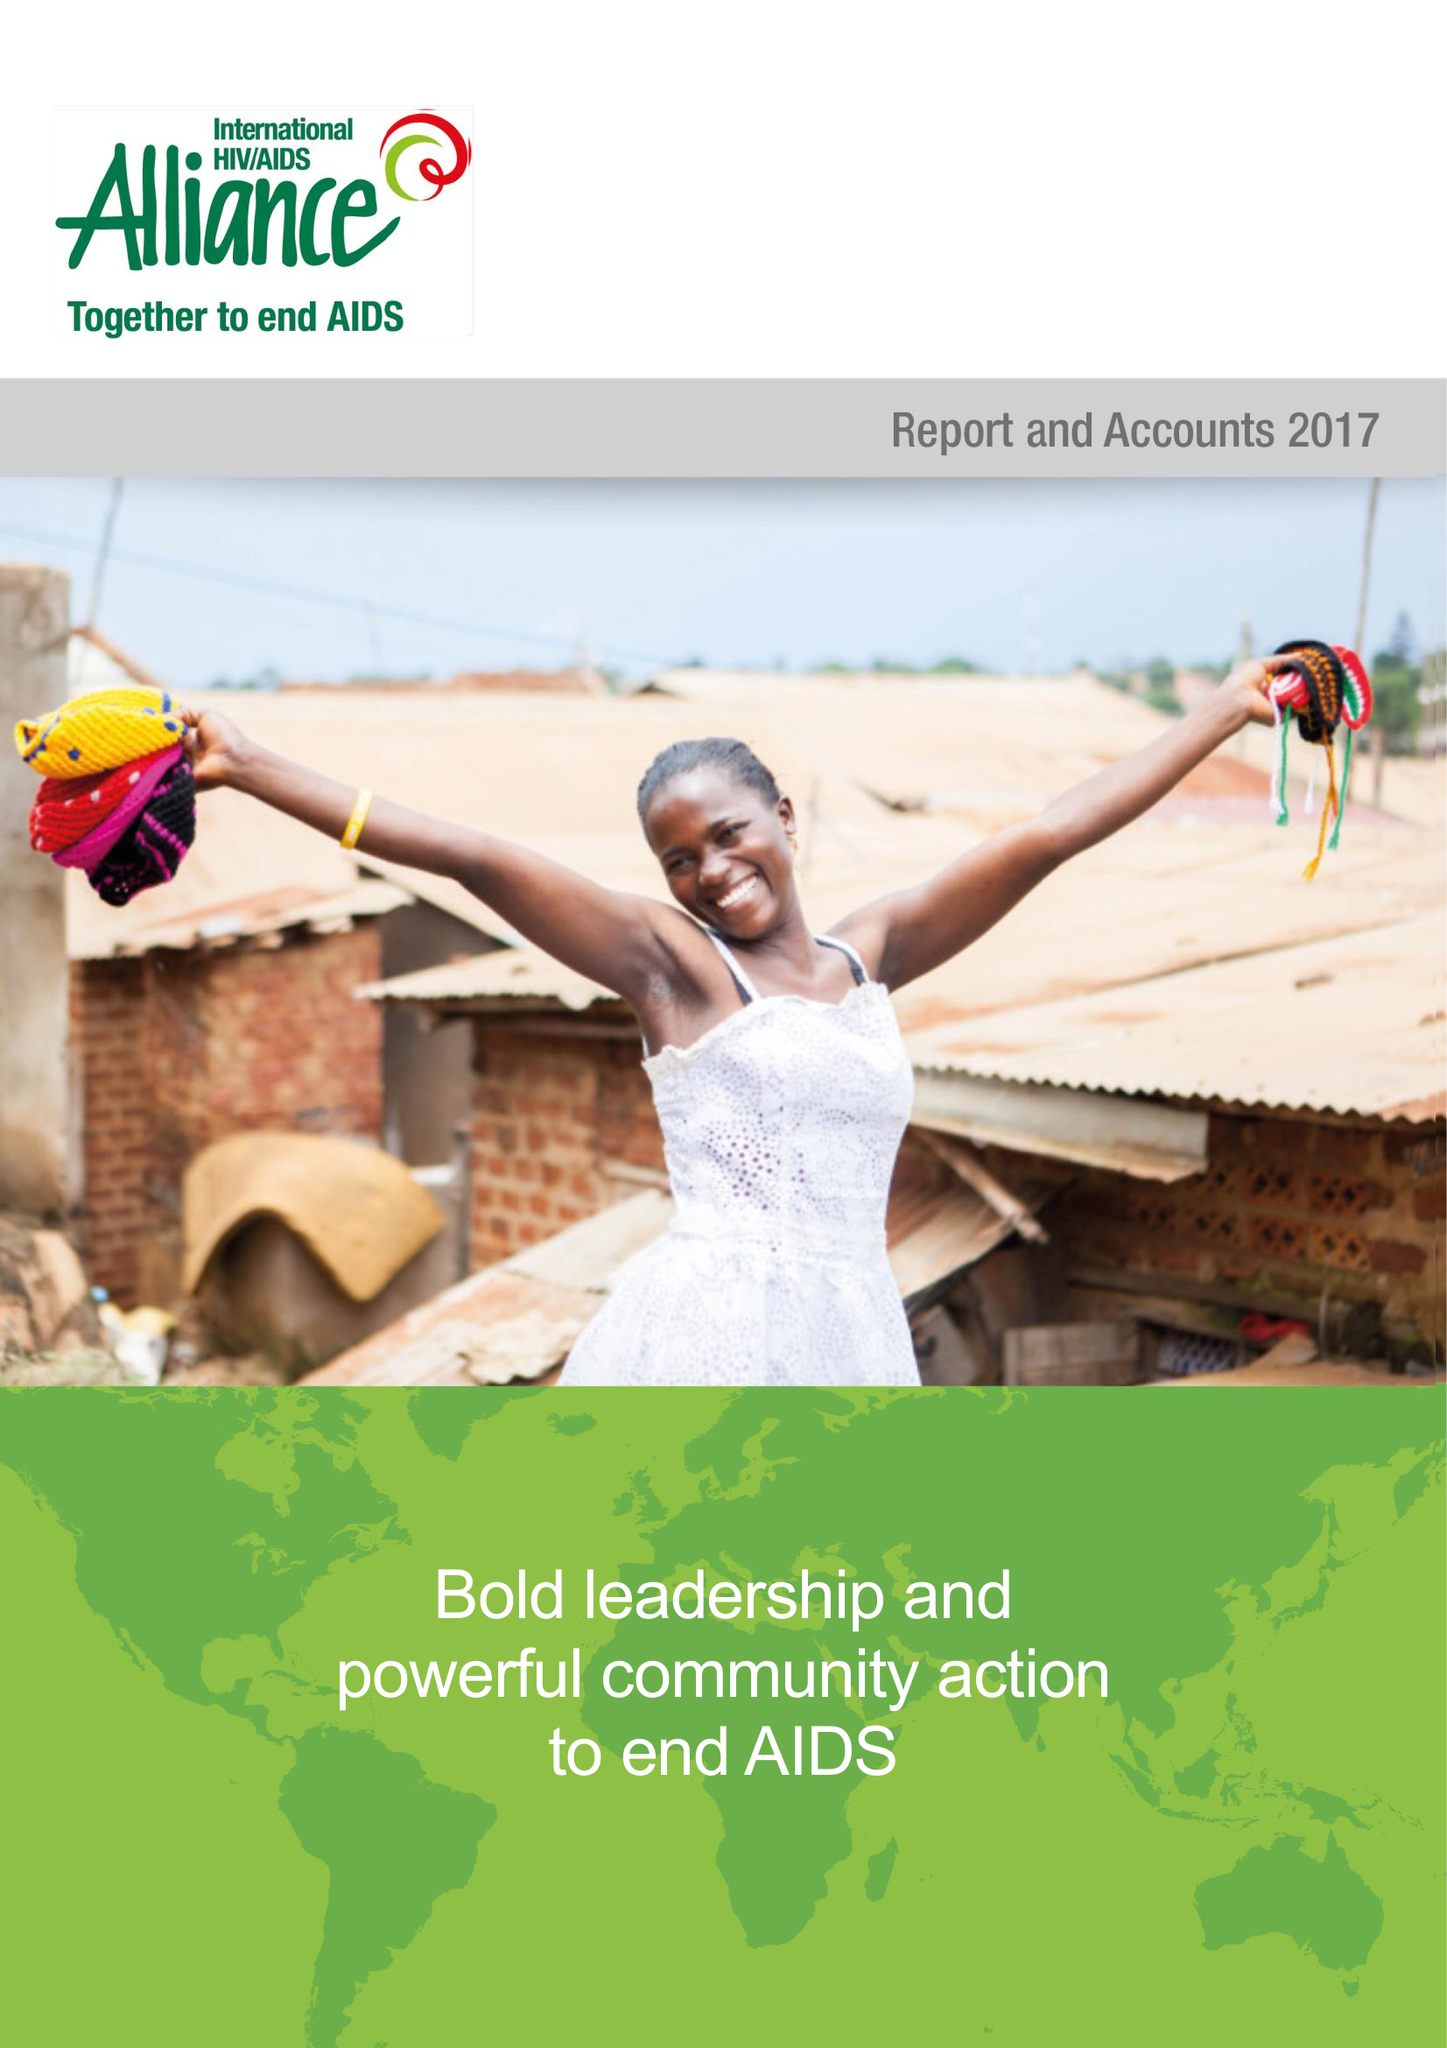What is the value for the address__street_line?
Answer the question using a single word or phrase. 91-101 DAVIGDOR ROAD 